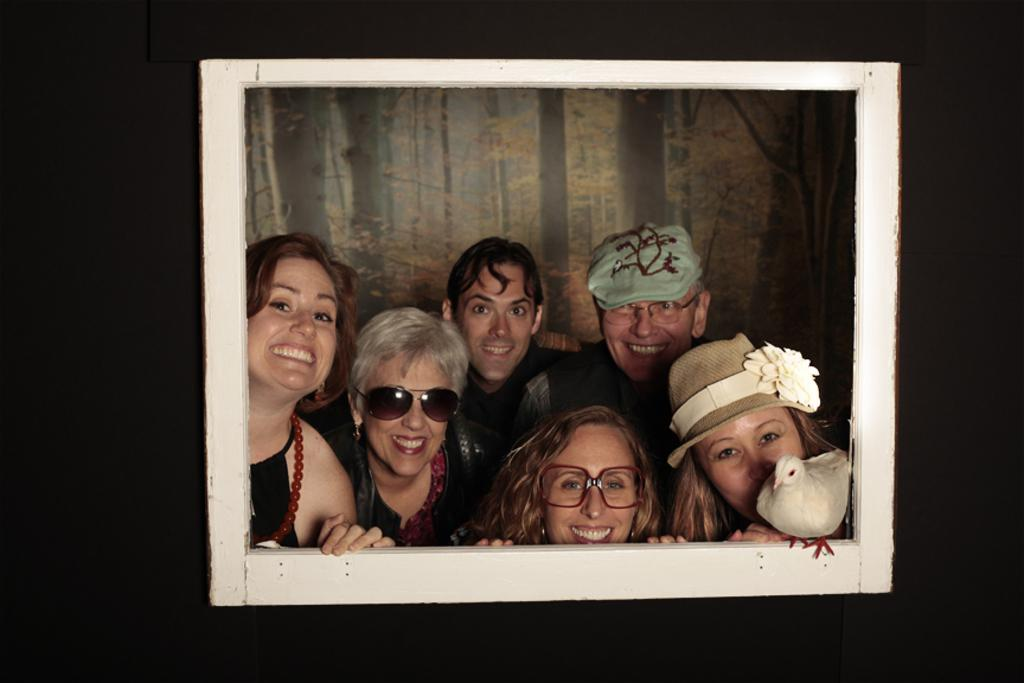What object is present in the image that typically holds a picture? There is a picture frame in the image. What can be seen inside the picture frame? There are people inside the picture frame. Is there any other living creature present on the picture frame? Yes, there is a bird on the picture frame. What type of background scenery is visible in the image? There is a background scenery of trees in the image. What type of crack can be seen on the church in the image? There is no church present in the image, so there cannot be any cracks on it. 